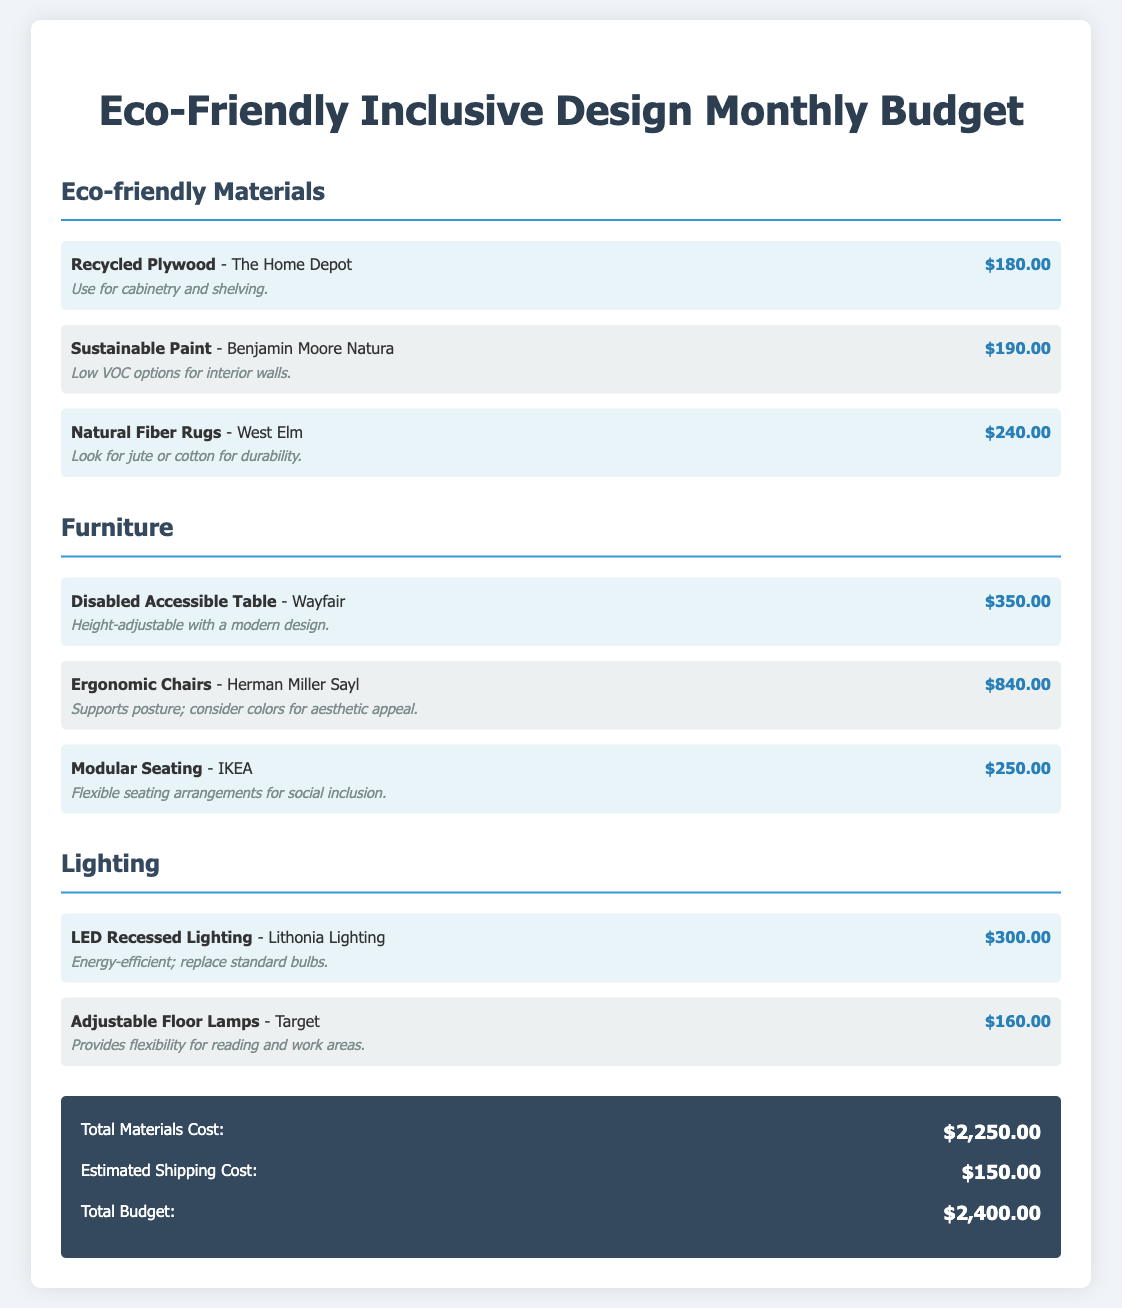what is the cost of Recycled Plywood? The cost of Recycled Plywood is listed in the budget as $180.00.
Answer: $180.00 what type of paint is used for sustainable options? The document mentions Benjamin Moore Natura as a sustainable paint option.
Answer: Benjamin Moore Natura how much does the Ergonomic Chair cost? The Ergonomic Chair is priced at $840.00 in the budget document.
Answer: $840.00 what is the total materials cost? The total materials cost is calculated as the sum of all listed materials, resulting in $2,250.00.
Answer: $2,250.00 how much is the estimated shipping cost? The estimated shipping cost provided in the document is $150.00.
Answer: $150.00 what type of lighting is mentioned for energy efficiency? The document specifies LED Recessed Lighting as an energy-efficient option.
Answer: LED Recessed Lighting which store offers Natural Fiber Rugs? Natural Fiber Rugs are available at West Elm, as stated in the document.
Answer: West Elm what is the budget for Modular Seating? The budget for Modular Seating is listed as $250.00.
Answer: $250.00 what is the total budget for the project? The total budget is the sum of materials and shipping costs, which amounts to $2,400.00.
Answer: $2,400.00 